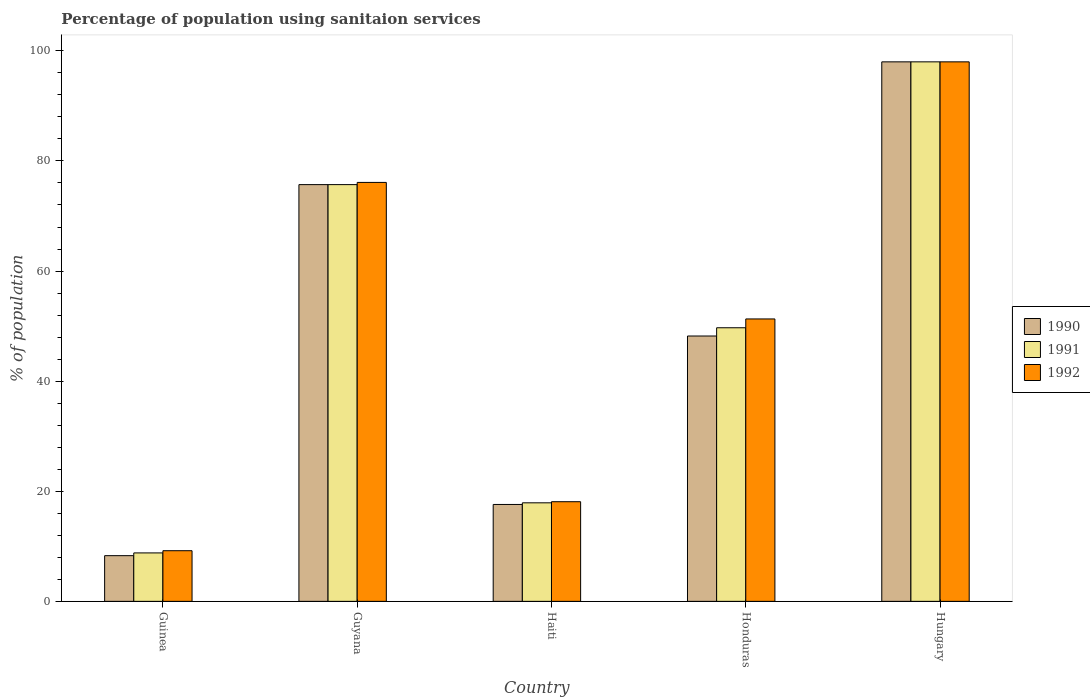How many groups of bars are there?
Your response must be concise. 5. Are the number of bars per tick equal to the number of legend labels?
Your answer should be very brief. Yes. How many bars are there on the 3rd tick from the left?
Ensure brevity in your answer.  3. How many bars are there on the 2nd tick from the right?
Offer a terse response. 3. What is the label of the 1st group of bars from the left?
Give a very brief answer. Guinea. In how many cases, is the number of bars for a given country not equal to the number of legend labels?
Your answer should be compact. 0. What is the percentage of population using sanitaion services in 1992 in Honduras?
Provide a succinct answer. 51.3. Across all countries, what is the maximum percentage of population using sanitaion services in 1990?
Offer a terse response. 98. Across all countries, what is the minimum percentage of population using sanitaion services in 1991?
Make the answer very short. 8.8. In which country was the percentage of population using sanitaion services in 1990 maximum?
Your answer should be compact. Hungary. In which country was the percentage of population using sanitaion services in 1990 minimum?
Your answer should be very brief. Guinea. What is the total percentage of population using sanitaion services in 1992 in the graph?
Keep it short and to the point. 252.7. What is the difference between the percentage of population using sanitaion services in 1992 in Guyana and that in Haiti?
Your answer should be compact. 58. What is the difference between the percentage of population using sanitaion services in 1991 in Hungary and the percentage of population using sanitaion services in 1992 in Honduras?
Provide a succinct answer. 46.7. What is the average percentage of population using sanitaion services in 1990 per country?
Offer a terse response. 49.56. What is the difference between the percentage of population using sanitaion services of/in 1991 and percentage of population using sanitaion services of/in 1992 in Guinea?
Offer a terse response. -0.4. What is the ratio of the percentage of population using sanitaion services in 1990 in Honduras to that in Hungary?
Keep it short and to the point. 0.49. Is the difference between the percentage of population using sanitaion services in 1991 in Haiti and Hungary greater than the difference between the percentage of population using sanitaion services in 1992 in Haiti and Hungary?
Give a very brief answer. No. What is the difference between the highest and the second highest percentage of population using sanitaion services in 1992?
Ensure brevity in your answer.  46.7. What is the difference between the highest and the lowest percentage of population using sanitaion services in 1992?
Ensure brevity in your answer.  88.8. In how many countries, is the percentage of population using sanitaion services in 1990 greater than the average percentage of population using sanitaion services in 1990 taken over all countries?
Offer a terse response. 2. Is the sum of the percentage of population using sanitaion services in 1991 in Guinea and Honduras greater than the maximum percentage of population using sanitaion services in 1990 across all countries?
Your answer should be very brief. No. How many bars are there?
Your answer should be compact. 15. Are all the bars in the graph horizontal?
Provide a short and direct response. No. How many countries are there in the graph?
Provide a short and direct response. 5. Does the graph contain any zero values?
Make the answer very short. No. Where does the legend appear in the graph?
Offer a very short reply. Center right. How many legend labels are there?
Provide a succinct answer. 3. What is the title of the graph?
Provide a succinct answer. Percentage of population using sanitaion services. Does "1986" appear as one of the legend labels in the graph?
Offer a very short reply. No. What is the label or title of the Y-axis?
Ensure brevity in your answer.  % of population. What is the % of population in 1990 in Guinea?
Provide a succinct answer. 8.3. What is the % of population of 1991 in Guinea?
Ensure brevity in your answer.  8.8. What is the % of population of 1990 in Guyana?
Provide a short and direct response. 75.7. What is the % of population of 1991 in Guyana?
Offer a very short reply. 75.7. What is the % of population of 1992 in Guyana?
Give a very brief answer. 76.1. What is the % of population of 1990 in Honduras?
Provide a short and direct response. 48.2. What is the % of population in 1991 in Honduras?
Provide a short and direct response. 49.7. What is the % of population in 1992 in Honduras?
Your answer should be very brief. 51.3. What is the % of population in 1991 in Hungary?
Make the answer very short. 98. Across all countries, what is the maximum % of population in 1990?
Ensure brevity in your answer.  98. Across all countries, what is the minimum % of population in 1991?
Offer a terse response. 8.8. Across all countries, what is the minimum % of population in 1992?
Make the answer very short. 9.2. What is the total % of population in 1990 in the graph?
Your answer should be very brief. 247.8. What is the total % of population of 1991 in the graph?
Provide a short and direct response. 250.1. What is the total % of population of 1992 in the graph?
Your answer should be compact. 252.7. What is the difference between the % of population of 1990 in Guinea and that in Guyana?
Make the answer very short. -67.4. What is the difference between the % of population in 1991 in Guinea and that in Guyana?
Your answer should be compact. -66.9. What is the difference between the % of population of 1992 in Guinea and that in Guyana?
Give a very brief answer. -66.9. What is the difference between the % of population in 1990 in Guinea and that in Haiti?
Your response must be concise. -9.3. What is the difference between the % of population in 1991 in Guinea and that in Haiti?
Make the answer very short. -9.1. What is the difference between the % of population in 1990 in Guinea and that in Honduras?
Your response must be concise. -39.9. What is the difference between the % of population of 1991 in Guinea and that in Honduras?
Your answer should be very brief. -40.9. What is the difference between the % of population in 1992 in Guinea and that in Honduras?
Offer a very short reply. -42.1. What is the difference between the % of population in 1990 in Guinea and that in Hungary?
Offer a terse response. -89.7. What is the difference between the % of population of 1991 in Guinea and that in Hungary?
Keep it short and to the point. -89.2. What is the difference between the % of population of 1992 in Guinea and that in Hungary?
Provide a short and direct response. -88.8. What is the difference between the % of population in 1990 in Guyana and that in Haiti?
Offer a terse response. 58.1. What is the difference between the % of population of 1991 in Guyana and that in Haiti?
Offer a terse response. 57.8. What is the difference between the % of population of 1990 in Guyana and that in Honduras?
Make the answer very short. 27.5. What is the difference between the % of population of 1992 in Guyana and that in Honduras?
Your answer should be compact. 24.8. What is the difference between the % of population of 1990 in Guyana and that in Hungary?
Make the answer very short. -22.3. What is the difference between the % of population of 1991 in Guyana and that in Hungary?
Your answer should be very brief. -22.3. What is the difference between the % of population of 1992 in Guyana and that in Hungary?
Your response must be concise. -21.9. What is the difference between the % of population of 1990 in Haiti and that in Honduras?
Your answer should be very brief. -30.6. What is the difference between the % of population of 1991 in Haiti and that in Honduras?
Offer a very short reply. -31.8. What is the difference between the % of population of 1992 in Haiti and that in Honduras?
Give a very brief answer. -33.2. What is the difference between the % of population of 1990 in Haiti and that in Hungary?
Keep it short and to the point. -80.4. What is the difference between the % of population in 1991 in Haiti and that in Hungary?
Your answer should be compact. -80.1. What is the difference between the % of population in 1992 in Haiti and that in Hungary?
Provide a succinct answer. -79.9. What is the difference between the % of population of 1990 in Honduras and that in Hungary?
Give a very brief answer. -49.8. What is the difference between the % of population in 1991 in Honduras and that in Hungary?
Your response must be concise. -48.3. What is the difference between the % of population of 1992 in Honduras and that in Hungary?
Your response must be concise. -46.7. What is the difference between the % of population in 1990 in Guinea and the % of population in 1991 in Guyana?
Your answer should be very brief. -67.4. What is the difference between the % of population in 1990 in Guinea and the % of population in 1992 in Guyana?
Give a very brief answer. -67.8. What is the difference between the % of population of 1991 in Guinea and the % of population of 1992 in Guyana?
Make the answer very short. -67.3. What is the difference between the % of population of 1990 in Guinea and the % of population of 1991 in Haiti?
Give a very brief answer. -9.6. What is the difference between the % of population of 1991 in Guinea and the % of population of 1992 in Haiti?
Provide a succinct answer. -9.3. What is the difference between the % of population in 1990 in Guinea and the % of population in 1991 in Honduras?
Make the answer very short. -41.4. What is the difference between the % of population in 1990 in Guinea and the % of population in 1992 in Honduras?
Provide a succinct answer. -43. What is the difference between the % of population of 1991 in Guinea and the % of population of 1992 in Honduras?
Keep it short and to the point. -42.5. What is the difference between the % of population in 1990 in Guinea and the % of population in 1991 in Hungary?
Provide a short and direct response. -89.7. What is the difference between the % of population of 1990 in Guinea and the % of population of 1992 in Hungary?
Your response must be concise. -89.7. What is the difference between the % of population of 1991 in Guinea and the % of population of 1992 in Hungary?
Your response must be concise. -89.2. What is the difference between the % of population of 1990 in Guyana and the % of population of 1991 in Haiti?
Make the answer very short. 57.8. What is the difference between the % of population of 1990 in Guyana and the % of population of 1992 in Haiti?
Make the answer very short. 57.6. What is the difference between the % of population in 1991 in Guyana and the % of population in 1992 in Haiti?
Your answer should be compact. 57.6. What is the difference between the % of population in 1990 in Guyana and the % of population in 1992 in Honduras?
Your response must be concise. 24.4. What is the difference between the % of population of 1991 in Guyana and the % of population of 1992 in Honduras?
Your answer should be very brief. 24.4. What is the difference between the % of population of 1990 in Guyana and the % of population of 1991 in Hungary?
Your answer should be compact. -22.3. What is the difference between the % of population of 1990 in Guyana and the % of population of 1992 in Hungary?
Your response must be concise. -22.3. What is the difference between the % of population of 1991 in Guyana and the % of population of 1992 in Hungary?
Keep it short and to the point. -22.3. What is the difference between the % of population of 1990 in Haiti and the % of population of 1991 in Honduras?
Ensure brevity in your answer.  -32.1. What is the difference between the % of population in 1990 in Haiti and the % of population in 1992 in Honduras?
Your response must be concise. -33.7. What is the difference between the % of population of 1991 in Haiti and the % of population of 1992 in Honduras?
Your answer should be compact. -33.4. What is the difference between the % of population of 1990 in Haiti and the % of population of 1991 in Hungary?
Offer a terse response. -80.4. What is the difference between the % of population in 1990 in Haiti and the % of population in 1992 in Hungary?
Offer a terse response. -80.4. What is the difference between the % of population in 1991 in Haiti and the % of population in 1992 in Hungary?
Make the answer very short. -80.1. What is the difference between the % of population of 1990 in Honduras and the % of population of 1991 in Hungary?
Your answer should be very brief. -49.8. What is the difference between the % of population of 1990 in Honduras and the % of population of 1992 in Hungary?
Offer a terse response. -49.8. What is the difference between the % of population of 1991 in Honduras and the % of population of 1992 in Hungary?
Offer a terse response. -48.3. What is the average % of population in 1990 per country?
Give a very brief answer. 49.56. What is the average % of population in 1991 per country?
Your answer should be very brief. 50.02. What is the average % of population in 1992 per country?
Your answer should be very brief. 50.54. What is the difference between the % of population of 1990 and % of population of 1992 in Guinea?
Offer a very short reply. -0.9. What is the difference between the % of population of 1990 and % of population of 1992 in Guyana?
Offer a very short reply. -0.4. What is the difference between the % of population in 1991 and % of population in 1992 in Guyana?
Provide a short and direct response. -0.4. What is the difference between the % of population in 1990 and % of population in 1991 in Haiti?
Offer a terse response. -0.3. What is the difference between the % of population in 1991 and % of population in 1992 in Haiti?
Your answer should be very brief. -0.2. What is the difference between the % of population in 1990 and % of population in 1991 in Honduras?
Keep it short and to the point. -1.5. What is the difference between the % of population in 1990 and % of population in 1992 in Honduras?
Your answer should be very brief. -3.1. What is the difference between the % of population of 1991 and % of population of 1992 in Honduras?
Offer a very short reply. -1.6. What is the difference between the % of population in 1990 and % of population in 1991 in Hungary?
Ensure brevity in your answer.  0. What is the ratio of the % of population in 1990 in Guinea to that in Guyana?
Your answer should be compact. 0.11. What is the ratio of the % of population in 1991 in Guinea to that in Guyana?
Provide a short and direct response. 0.12. What is the ratio of the % of population of 1992 in Guinea to that in Guyana?
Your answer should be very brief. 0.12. What is the ratio of the % of population in 1990 in Guinea to that in Haiti?
Provide a short and direct response. 0.47. What is the ratio of the % of population of 1991 in Guinea to that in Haiti?
Offer a very short reply. 0.49. What is the ratio of the % of population of 1992 in Guinea to that in Haiti?
Ensure brevity in your answer.  0.51. What is the ratio of the % of population in 1990 in Guinea to that in Honduras?
Ensure brevity in your answer.  0.17. What is the ratio of the % of population of 1991 in Guinea to that in Honduras?
Provide a succinct answer. 0.18. What is the ratio of the % of population in 1992 in Guinea to that in Honduras?
Provide a short and direct response. 0.18. What is the ratio of the % of population of 1990 in Guinea to that in Hungary?
Your response must be concise. 0.08. What is the ratio of the % of population of 1991 in Guinea to that in Hungary?
Provide a succinct answer. 0.09. What is the ratio of the % of population in 1992 in Guinea to that in Hungary?
Your answer should be compact. 0.09. What is the ratio of the % of population of 1990 in Guyana to that in Haiti?
Provide a succinct answer. 4.3. What is the ratio of the % of population of 1991 in Guyana to that in Haiti?
Ensure brevity in your answer.  4.23. What is the ratio of the % of population of 1992 in Guyana to that in Haiti?
Make the answer very short. 4.2. What is the ratio of the % of population of 1990 in Guyana to that in Honduras?
Keep it short and to the point. 1.57. What is the ratio of the % of population of 1991 in Guyana to that in Honduras?
Offer a very short reply. 1.52. What is the ratio of the % of population in 1992 in Guyana to that in Honduras?
Give a very brief answer. 1.48. What is the ratio of the % of population of 1990 in Guyana to that in Hungary?
Offer a very short reply. 0.77. What is the ratio of the % of population of 1991 in Guyana to that in Hungary?
Give a very brief answer. 0.77. What is the ratio of the % of population in 1992 in Guyana to that in Hungary?
Make the answer very short. 0.78. What is the ratio of the % of population of 1990 in Haiti to that in Honduras?
Offer a terse response. 0.37. What is the ratio of the % of population of 1991 in Haiti to that in Honduras?
Provide a short and direct response. 0.36. What is the ratio of the % of population in 1992 in Haiti to that in Honduras?
Your answer should be very brief. 0.35. What is the ratio of the % of population of 1990 in Haiti to that in Hungary?
Provide a succinct answer. 0.18. What is the ratio of the % of population in 1991 in Haiti to that in Hungary?
Offer a terse response. 0.18. What is the ratio of the % of population of 1992 in Haiti to that in Hungary?
Give a very brief answer. 0.18. What is the ratio of the % of population of 1990 in Honduras to that in Hungary?
Ensure brevity in your answer.  0.49. What is the ratio of the % of population in 1991 in Honduras to that in Hungary?
Provide a short and direct response. 0.51. What is the ratio of the % of population of 1992 in Honduras to that in Hungary?
Provide a succinct answer. 0.52. What is the difference between the highest and the second highest % of population in 1990?
Provide a short and direct response. 22.3. What is the difference between the highest and the second highest % of population in 1991?
Offer a very short reply. 22.3. What is the difference between the highest and the second highest % of population in 1992?
Give a very brief answer. 21.9. What is the difference between the highest and the lowest % of population of 1990?
Offer a terse response. 89.7. What is the difference between the highest and the lowest % of population of 1991?
Your answer should be very brief. 89.2. What is the difference between the highest and the lowest % of population of 1992?
Ensure brevity in your answer.  88.8. 